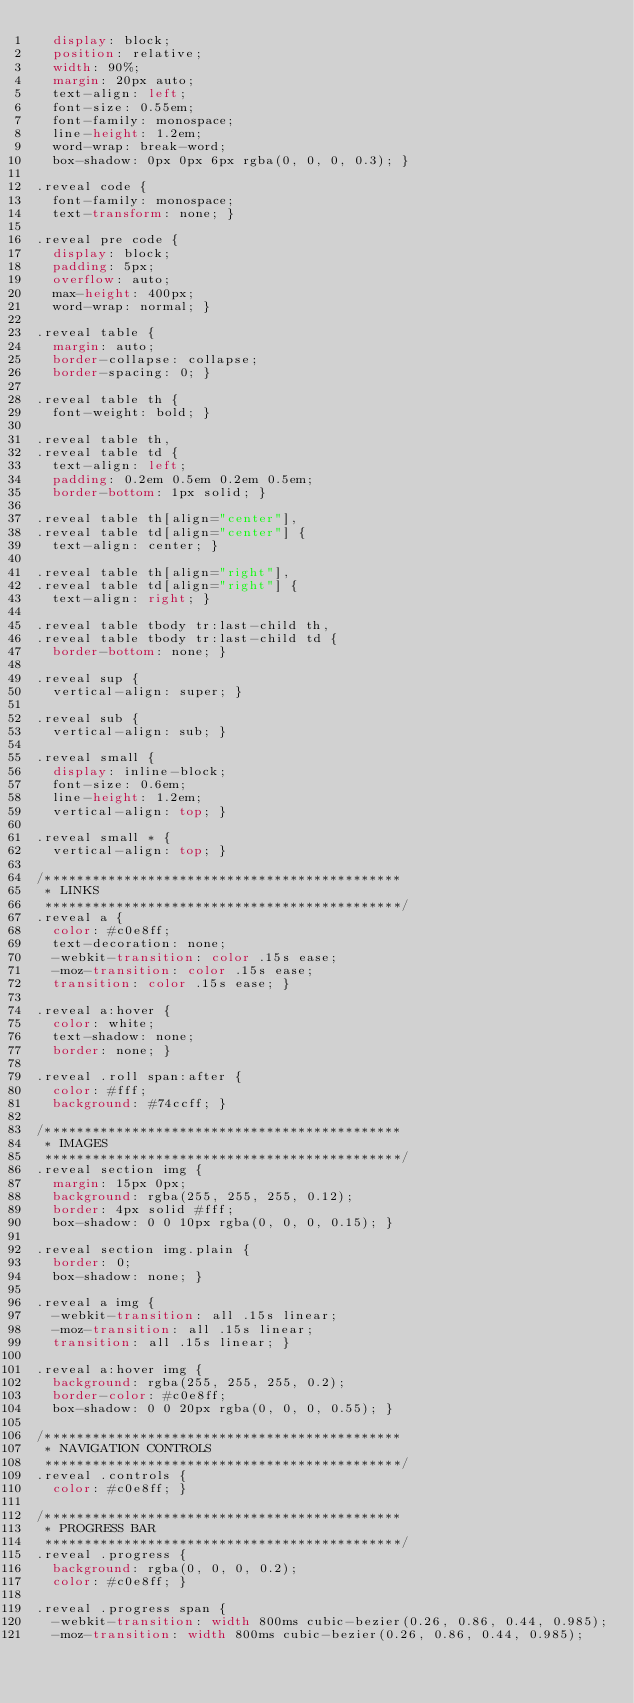Convert code to text. <code><loc_0><loc_0><loc_500><loc_500><_CSS_>  display: block;
  position: relative;
  width: 90%;
  margin: 20px auto;
  text-align: left;
  font-size: 0.55em;
  font-family: monospace;
  line-height: 1.2em;
  word-wrap: break-word;
  box-shadow: 0px 0px 6px rgba(0, 0, 0, 0.3); }

.reveal code {
  font-family: monospace;
  text-transform: none; }

.reveal pre code {
  display: block;
  padding: 5px;
  overflow: auto;
  max-height: 400px;
  word-wrap: normal; }

.reveal table {
  margin: auto;
  border-collapse: collapse;
  border-spacing: 0; }

.reveal table th {
  font-weight: bold; }

.reveal table th,
.reveal table td {
  text-align: left;
  padding: 0.2em 0.5em 0.2em 0.5em;
  border-bottom: 1px solid; }

.reveal table th[align="center"],
.reveal table td[align="center"] {
  text-align: center; }

.reveal table th[align="right"],
.reveal table td[align="right"] {
  text-align: right; }

.reveal table tbody tr:last-child th,
.reveal table tbody tr:last-child td {
  border-bottom: none; }

.reveal sup {
  vertical-align: super; }

.reveal sub {
  vertical-align: sub; }

.reveal small {
  display: inline-block;
  font-size: 0.6em;
  line-height: 1.2em;
  vertical-align: top; }

.reveal small * {
  vertical-align: top; }

/*********************************************
 * LINKS
 *********************************************/
.reveal a {
  color: #c0e8ff;
  text-decoration: none;
  -webkit-transition: color .15s ease;
  -moz-transition: color .15s ease;
  transition: color .15s ease; }

.reveal a:hover {
  color: white;
  text-shadow: none;
  border: none; }

.reveal .roll span:after {
  color: #fff;
  background: #74ccff; }

/*********************************************
 * IMAGES
 *********************************************/
.reveal section img {
  margin: 15px 0px;
  background: rgba(255, 255, 255, 0.12);
  border: 4px solid #fff;
  box-shadow: 0 0 10px rgba(0, 0, 0, 0.15); }

.reveal section img.plain {
  border: 0;
  box-shadow: none; }

.reveal a img {
  -webkit-transition: all .15s linear;
  -moz-transition: all .15s linear;
  transition: all .15s linear; }

.reveal a:hover img {
  background: rgba(255, 255, 255, 0.2);
  border-color: #c0e8ff;
  box-shadow: 0 0 20px rgba(0, 0, 0, 0.55); }

/*********************************************
 * NAVIGATION CONTROLS
 *********************************************/
.reveal .controls {
  color: #c0e8ff; }

/*********************************************
 * PROGRESS BAR
 *********************************************/
.reveal .progress {
  background: rgba(0, 0, 0, 0.2);
  color: #c0e8ff; }

.reveal .progress span {
  -webkit-transition: width 800ms cubic-bezier(0.26, 0.86, 0.44, 0.985);
  -moz-transition: width 800ms cubic-bezier(0.26, 0.86, 0.44, 0.985);</code> 